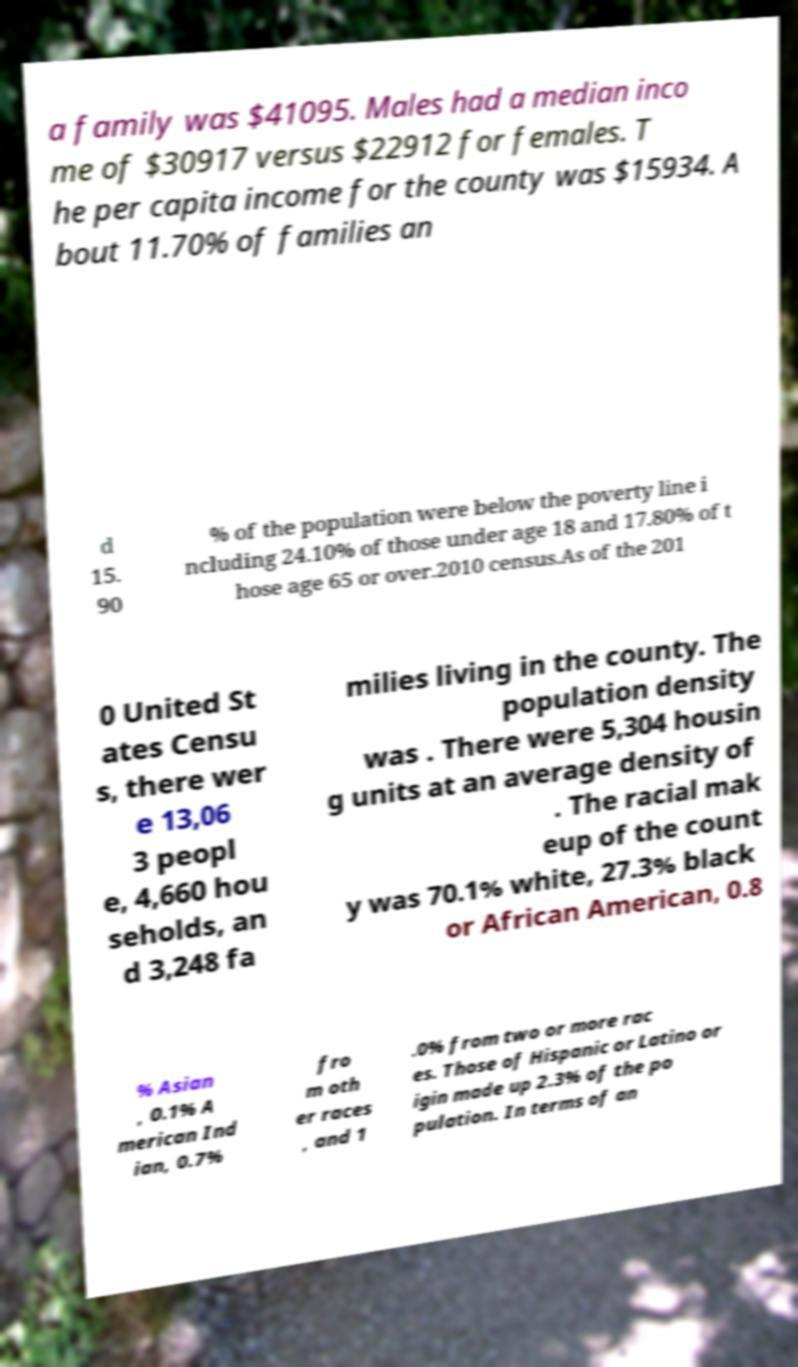I need the written content from this picture converted into text. Can you do that? a family was $41095. Males had a median inco me of $30917 versus $22912 for females. T he per capita income for the county was $15934. A bout 11.70% of families an d 15. 90 % of the population were below the poverty line i ncluding 24.10% of those under age 18 and 17.80% of t hose age 65 or over.2010 census.As of the 201 0 United St ates Censu s, there wer e 13,06 3 peopl e, 4,660 hou seholds, an d 3,248 fa milies living in the county. The population density was . There were 5,304 housin g units at an average density of . The racial mak eup of the count y was 70.1% white, 27.3% black or African American, 0.8 % Asian , 0.1% A merican Ind ian, 0.7% fro m oth er races , and 1 .0% from two or more rac es. Those of Hispanic or Latino or igin made up 2.3% of the po pulation. In terms of an 